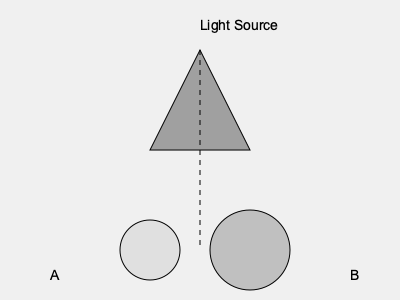A triangular prism is illuminated from above, casting shadows on a flat surface below. Two possible shadow shapes are shown, labeled A and B. Which shadow shape is correct if the light source is directly above the prism's apex? To determine the correct shadow shape, let's analyze the problem step-by-step:

1. Light source position: The light is directly above the prism's apex (top vertex).

2. Prism orientation: The prism is standing vertically, with its base parallel to the ground.

3. Shadow formation principles:
   a) Shadows are formed in the opposite direction of the light source.
   b) The shape of a shadow depends on the object's shape and the angle of the light.

4. Analysis of shadow A (left circle):
   - This shadow is smaller and doesn't reflect the triangular shape of the prism.
   - It suggests a light source that's not directly above the apex.

5. Analysis of shadow B (right circle):
   - This shadow is larger and maintains a triangular shape.
   - It accurately represents a projection of the prism when light is directly above.

6. Projection logic:
   - When light is directly above an object, the shadow will be directly below it.
   - The shadow's shape will be similar to the object's base shape, which in this case is triangular.

7. Error resolution perspective:
   - In database or system management, accurate representation of data is crucial.
   - The correct shadow (B) represents a more accurate "output" based on the given "input" (light source position).

Therefore, shadow B is the correct representation of the prism's shadow when the light source is directly above its apex.
Answer: B 